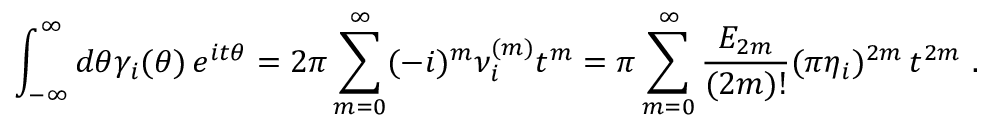<formula> <loc_0><loc_0><loc_500><loc_500>\int _ { - \infty } ^ { \infty } d \theta \gamma _ { i } ( \theta ) \, e ^ { i t \theta } = 2 \pi \sum _ { m = 0 } ^ { \infty } ( - i ) ^ { m } \nu _ { i } ^ { ( m ) } t ^ { m } = \pi \sum _ { m = 0 } ^ { \infty } \frac { E _ { 2 m } } { ( 2 m ) ! } ( \pi \eta _ { i } ) ^ { 2 m } \, t ^ { 2 m } \, .</formula> 